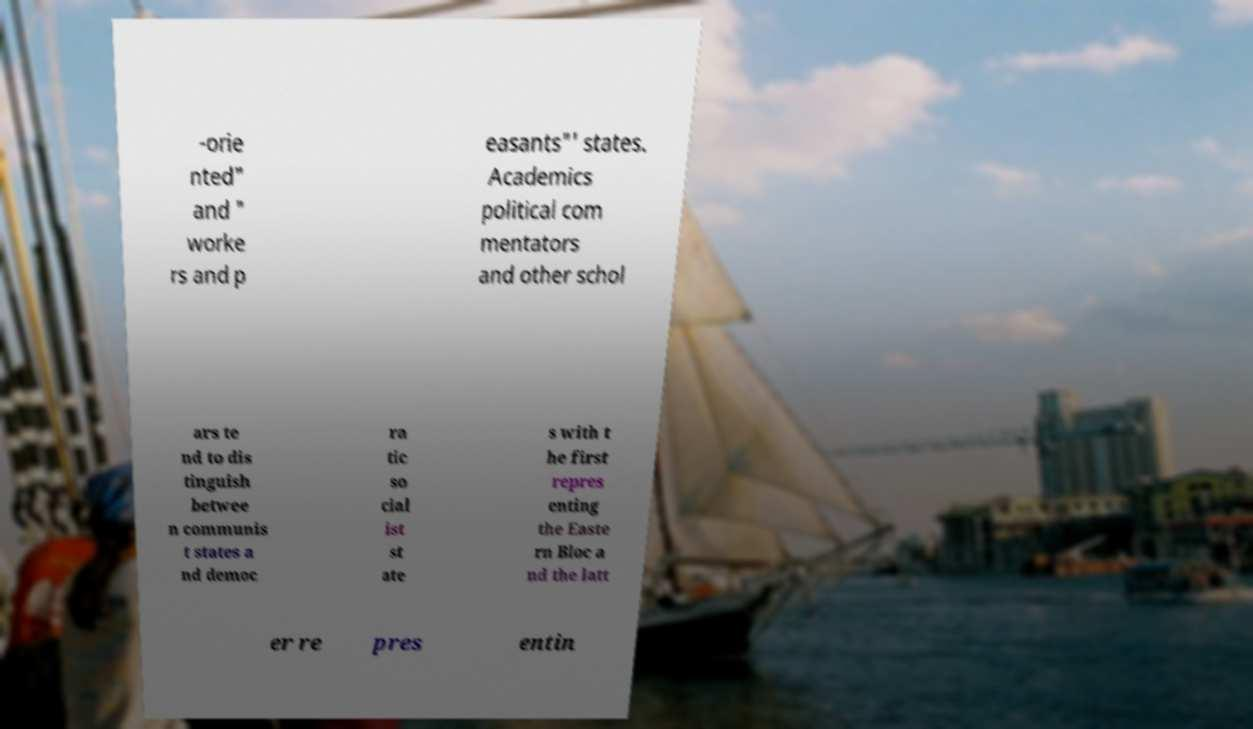Could you extract and type out the text from this image? -orie nted" and " worke rs and p easants"' states. Academics political com mentators and other schol ars te nd to dis tinguish betwee n communis t states a nd democ ra tic so cial ist st ate s with t he first repres enting the Easte rn Bloc a nd the latt er re pres entin 